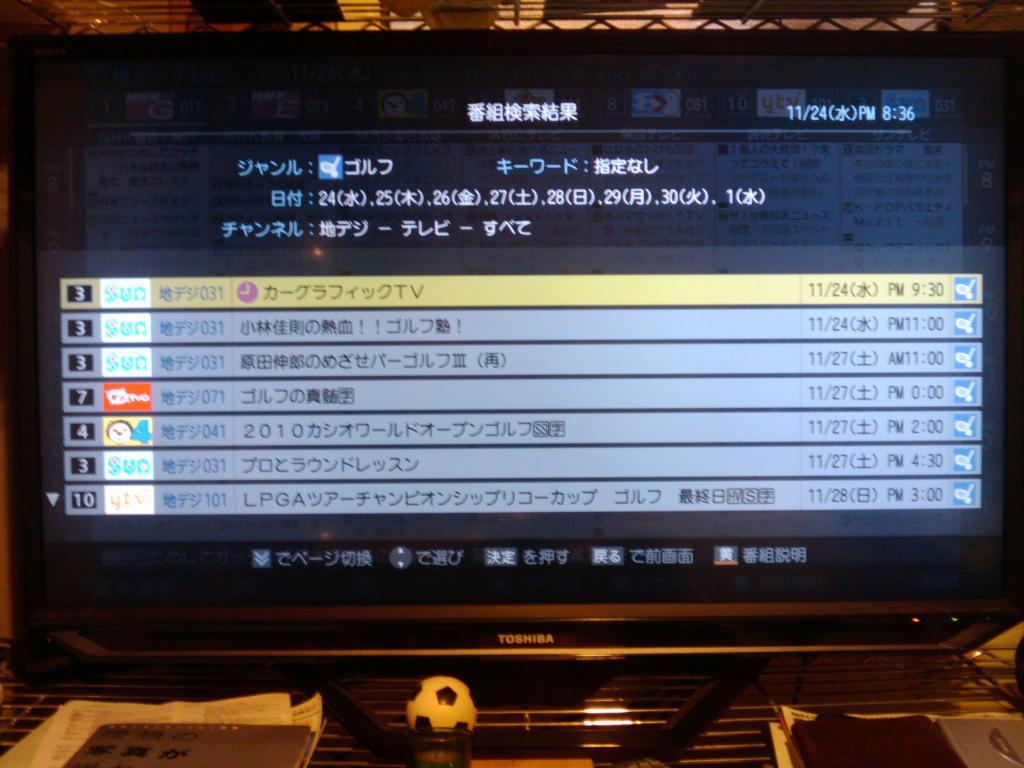<image>
Offer a succinct explanation of the picture presented. The number 3 and 7 can be seen on the left side of a computer screen 